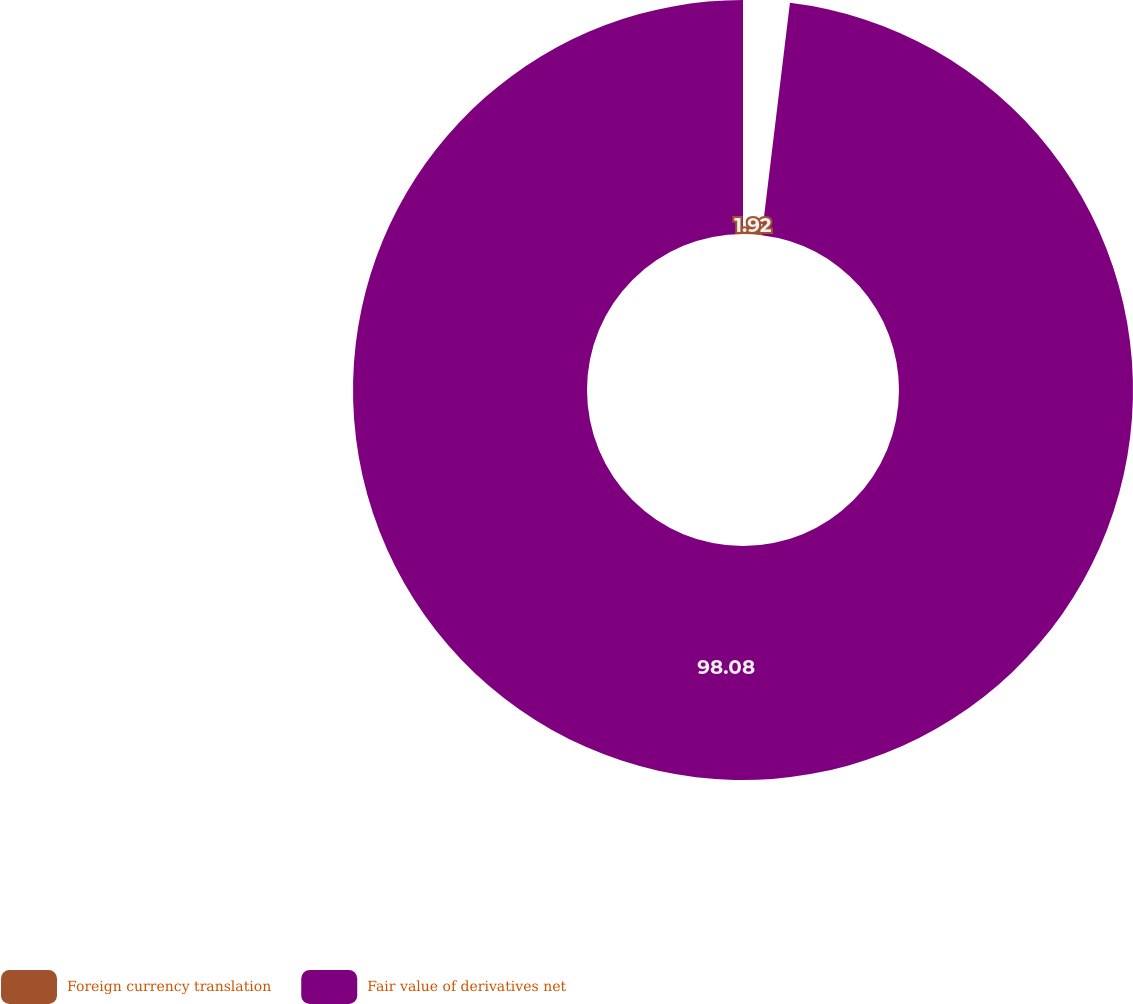Convert chart to OTSL. <chart><loc_0><loc_0><loc_500><loc_500><pie_chart><fcel>Foreign currency translation<fcel>Fair value of derivatives net<nl><fcel>1.92%<fcel>98.08%<nl></chart> 